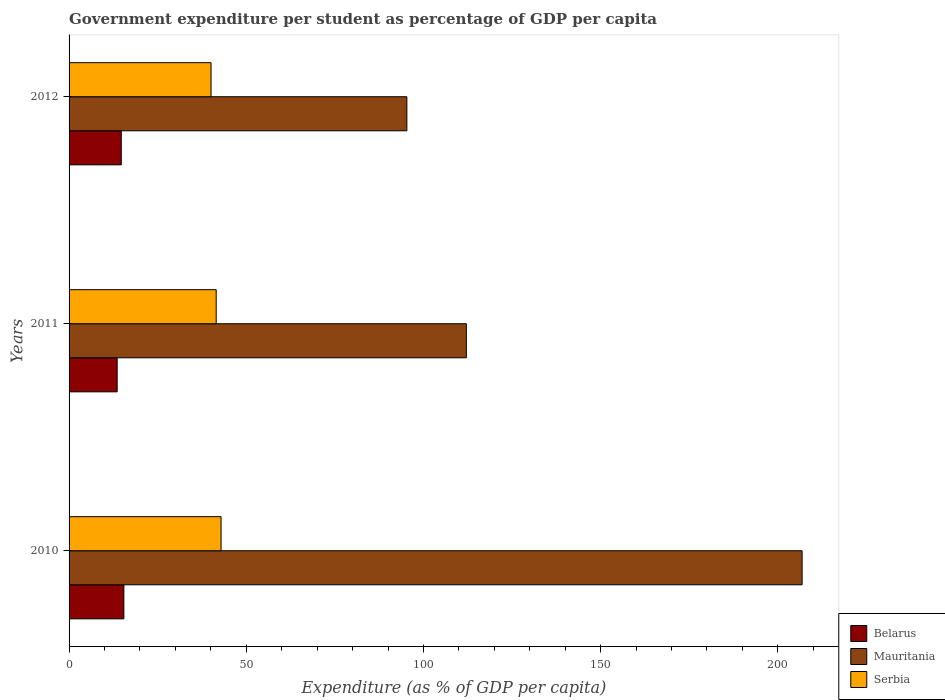How many groups of bars are there?
Your answer should be compact. 3. How many bars are there on the 1st tick from the top?
Provide a short and direct response. 3. How many bars are there on the 3rd tick from the bottom?
Your answer should be very brief. 3. In how many cases, is the number of bars for a given year not equal to the number of legend labels?
Keep it short and to the point. 0. What is the percentage of expenditure per student in Serbia in 2012?
Ensure brevity in your answer.  40.06. Across all years, what is the maximum percentage of expenditure per student in Mauritania?
Make the answer very short. 206.85. Across all years, what is the minimum percentage of expenditure per student in Mauritania?
Provide a succinct answer. 95.32. In which year was the percentage of expenditure per student in Serbia maximum?
Give a very brief answer. 2010. What is the total percentage of expenditure per student in Serbia in the graph?
Provide a succinct answer. 124.47. What is the difference between the percentage of expenditure per student in Serbia in 2010 and that in 2012?
Your answer should be compact. 2.82. What is the difference between the percentage of expenditure per student in Belarus in 2011 and the percentage of expenditure per student in Serbia in 2012?
Keep it short and to the point. -26.49. What is the average percentage of expenditure per student in Mauritania per year?
Provide a succinct answer. 138.09. In the year 2012, what is the difference between the percentage of expenditure per student in Serbia and percentage of expenditure per student in Mauritania?
Your answer should be very brief. -55.26. What is the ratio of the percentage of expenditure per student in Mauritania in 2010 to that in 2012?
Offer a very short reply. 2.17. Is the percentage of expenditure per student in Serbia in 2010 less than that in 2012?
Offer a very short reply. No. Is the difference between the percentage of expenditure per student in Serbia in 2010 and 2011 greater than the difference between the percentage of expenditure per student in Mauritania in 2010 and 2011?
Provide a succinct answer. No. What is the difference between the highest and the second highest percentage of expenditure per student in Serbia?
Offer a terse response. 1.37. What is the difference between the highest and the lowest percentage of expenditure per student in Mauritania?
Your answer should be very brief. 111.53. In how many years, is the percentage of expenditure per student in Mauritania greater than the average percentage of expenditure per student in Mauritania taken over all years?
Make the answer very short. 1. Is the sum of the percentage of expenditure per student in Serbia in 2011 and 2012 greater than the maximum percentage of expenditure per student in Belarus across all years?
Provide a succinct answer. Yes. What does the 1st bar from the top in 2012 represents?
Make the answer very short. Serbia. What does the 3rd bar from the bottom in 2011 represents?
Provide a short and direct response. Serbia. Is it the case that in every year, the sum of the percentage of expenditure per student in Serbia and percentage of expenditure per student in Belarus is greater than the percentage of expenditure per student in Mauritania?
Your answer should be very brief. No. How many years are there in the graph?
Your answer should be very brief. 3. What is the difference between two consecutive major ticks on the X-axis?
Offer a terse response. 50. Where does the legend appear in the graph?
Provide a short and direct response. Bottom right. What is the title of the graph?
Your answer should be compact. Government expenditure per student as percentage of GDP per capita. What is the label or title of the X-axis?
Provide a short and direct response. Expenditure (as % of GDP per capita). What is the label or title of the Y-axis?
Your response must be concise. Years. What is the Expenditure (as % of GDP per capita) of Belarus in 2010?
Provide a short and direct response. 15.46. What is the Expenditure (as % of GDP per capita) in Mauritania in 2010?
Keep it short and to the point. 206.85. What is the Expenditure (as % of GDP per capita) of Serbia in 2010?
Your answer should be very brief. 42.89. What is the Expenditure (as % of GDP per capita) of Belarus in 2011?
Provide a short and direct response. 13.57. What is the Expenditure (as % of GDP per capita) in Mauritania in 2011?
Give a very brief answer. 112.11. What is the Expenditure (as % of GDP per capita) in Serbia in 2011?
Give a very brief answer. 41.52. What is the Expenditure (as % of GDP per capita) of Belarus in 2012?
Offer a terse response. 14.73. What is the Expenditure (as % of GDP per capita) in Mauritania in 2012?
Offer a terse response. 95.32. What is the Expenditure (as % of GDP per capita) of Serbia in 2012?
Give a very brief answer. 40.06. Across all years, what is the maximum Expenditure (as % of GDP per capita) in Belarus?
Your answer should be compact. 15.46. Across all years, what is the maximum Expenditure (as % of GDP per capita) in Mauritania?
Your answer should be very brief. 206.85. Across all years, what is the maximum Expenditure (as % of GDP per capita) of Serbia?
Ensure brevity in your answer.  42.89. Across all years, what is the minimum Expenditure (as % of GDP per capita) of Belarus?
Offer a terse response. 13.57. Across all years, what is the minimum Expenditure (as % of GDP per capita) in Mauritania?
Provide a short and direct response. 95.32. Across all years, what is the minimum Expenditure (as % of GDP per capita) of Serbia?
Your answer should be very brief. 40.06. What is the total Expenditure (as % of GDP per capita) in Belarus in the graph?
Your response must be concise. 43.76. What is the total Expenditure (as % of GDP per capita) of Mauritania in the graph?
Your answer should be very brief. 414.28. What is the total Expenditure (as % of GDP per capita) in Serbia in the graph?
Give a very brief answer. 124.47. What is the difference between the Expenditure (as % of GDP per capita) of Belarus in 2010 and that in 2011?
Make the answer very short. 1.89. What is the difference between the Expenditure (as % of GDP per capita) of Mauritania in 2010 and that in 2011?
Your answer should be very brief. 94.74. What is the difference between the Expenditure (as % of GDP per capita) of Serbia in 2010 and that in 2011?
Your response must be concise. 1.37. What is the difference between the Expenditure (as % of GDP per capita) of Belarus in 2010 and that in 2012?
Keep it short and to the point. 0.73. What is the difference between the Expenditure (as % of GDP per capita) of Mauritania in 2010 and that in 2012?
Give a very brief answer. 111.53. What is the difference between the Expenditure (as % of GDP per capita) in Serbia in 2010 and that in 2012?
Your response must be concise. 2.82. What is the difference between the Expenditure (as % of GDP per capita) in Belarus in 2011 and that in 2012?
Offer a very short reply. -1.16. What is the difference between the Expenditure (as % of GDP per capita) in Mauritania in 2011 and that in 2012?
Offer a terse response. 16.79. What is the difference between the Expenditure (as % of GDP per capita) in Serbia in 2011 and that in 2012?
Provide a succinct answer. 1.45. What is the difference between the Expenditure (as % of GDP per capita) in Belarus in 2010 and the Expenditure (as % of GDP per capita) in Mauritania in 2011?
Offer a terse response. -96.65. What is the difference between the Expenditure (as % of GDP per capita) in Belarus in 2010 and the Expenditure (as % of GDP per capita) in Serbia in 2011?
Give a very brief answer. -26.06. What is the difference between the Expenditure (as % of GDP per capita) of Mauritania in 2010 and the Expenditure (as % of GDP per capita) of Serbia in 2011?
Provide a succinct answer. 165.34. What is the difference between the Expenditure (as % of GDP per capita) of Belarus in 2010 and the Expenditure (as % of GDP per capita) of Mauritania in 2012?
Keep it short and to the point. -79.86. What is the difference between the Expenditure (as % of GDP per capita) in Belarus in 2010 and the Expenditure (as % of GDP per capita) in Serbia in 2012?
Give a very brief answer. -24.6. What is the difference between the Expenditure (as % of GDP per capita) of Mauritania in 2010 and the Expenditure (as % of GDP per capita) of Serbia in 2012?
Your answer should be compact. 166.79. What is the difference between the Expenditure (as % of GDP per capita) of Belarus in 2011 and the Expenditure (as % of GDP per capita) of Mauritania in 2012?
Make the answer very short. -81.75. What is the difference between the Expenditure (as % of GDP per capita) in Belarus in 2011 and the Expenditure (as % of GDP per capita) in Serbia in 2012?
Provide a short and direct response. -26.49. What is the difference between the Expenditure (as % of GDP per capita) of Mauritania in 2011 and the Expenditure (as % of GDP per capita) of Serbia in 2012?
Offer a terse response. 72.05. What is the average Expenditure (as % of GDP per capita) in Belarus per year?
Your response must be concise. 14.59. What is the average Expenditure (as % of GDP per capita) of Mauritania per year?
Make the answer very short. 138.09. What is the average Expenditure (as % of GDP per capita) in Serbia per year?
Your answer should be compact. 41.49. In the year 2010, what is the difference between the Expenditure (as % of GDP per capita) of Belarus and Expenditure (as % of GDP per capita) of Mauritania?
Your response must be concise. -191.39. In the year 2010, what is the difference between the Expenditure (as % of GDP per capita) of Belarus and Expenditure (as % of GDP per capita) of Serbia?
Your answer should be compact. -27.43. In the year 2010, what is the difference between the Expenditure (as % of GDP per capita) of Mauritania and Expenditure (as % of GDP per capita) of Serbia?
Provide a short and direct response. 163.96. In the year 2011, what is the difference between the Expenditure (as % of GDP per capita) of Belarus and Expenditure (as % of GDP per capita) of Mauritania?
Your answer should be very brief. -98.54. In the year 2011, what is the difference between the Expenditure (as % of GDP per capita) in Belarus and Expenditure (as % of GDP per capita) in Serbia?
Give a very brief answer. -27.95. In the year 2011, what is the difference between the Expenditure (as % of GDP per capita) of Mauritania and Expenditure (as % of GDP per capita) of Serbia?
Make the answer very short. 70.6. In the year 2012, what is the difference between the Expenditure (as % of GDP per capita) in Belarus and Expenditure (as % of GDP per capita) in Mauritania?
Your answer should be very brief. -80.59. In the year 2012, what is the difference between the Expenditure (as % of GDP per capita) of Belarus and Expenditure (as % of GDP per capita) of Serbia?
Your answer should be very brief. -25.33. In the year 2012, what is the difference between the Expenditure (as % of GDP per capita) in Mauritania and Expenditure (as % of GDP per capita) in Serbia?
Provide a succinct answer. 55.26. What is the ratio of the Expenditure (as % of GDP per capita) of Belarus in 2010 to that in 2011?
Ensure brevity in your answer.  1.14. What is the ratio of the Expenditure (as % of GDP per capita) in Mauritania in 2010 to that in 2011?
Provide a short and direct response. 1.84. What is the ratio of the Expenditure (as % of GDP per capita) of Serbia in 2010 to that in 2011?
Keep it short and to the point. 1.03. What is the ratio of the Expenditure (as % of GDP per capita) in Belarus in 2010 to that in 2012?
Your answer should be very brief. 1.05. What is the ratio of the Expenditure (as % of GDP per capita) of Mauritania in 2010 to that in 2012?
Ensure brevity in your answer.  2.17. What is the ratio of the Expenditure (as % of GDP per capita) of Serbia in 2010 to that in 2012?
Your answer should be very brief. 1.07. What is the ratio of the Expenditure (as % of GDP per capita) in Belarus in 2011 to that in 2012?
Make the answer very short. 0.92. What is the ratio of the Expenditure (as % of GDP per capita) in Mauritania in 2011 to that in 2012?
Make the answer very short. 1.18. What is the ratio of the Expenditure (as % of GDP per capita) of Serbia in 2011 to that in 2012?
Offer a terse response. 1.04. What is the difference between the highest and the second highest Expenditure (as % of GDP per capita) in Belarus?
Ensure brevity in your answer.  0.73. What is the difference between the highest and the second highest Expenditure (as % of GDP per capita) of Mauritania?
Give a very brief answer. 94.74. What is the difference between the highest and the second highest Expenditure (as % of GDP per capita) in Serbia?
Your response must be concise. 1.37. What is the difference between the highest and the lowest Expenditure (as % of GDP per capita) in Belarus?
Your answer should be compact. 1.89. What is the difference between the highest and the lowest Expenditure (as % of GDP per capita) in Mauritania?
Make the answer very short. 111.53. What is the difference between the highest and the lowest Expenditure (as % of GDP per capita) of Serbia?
Offer a terse response. 2.82. 